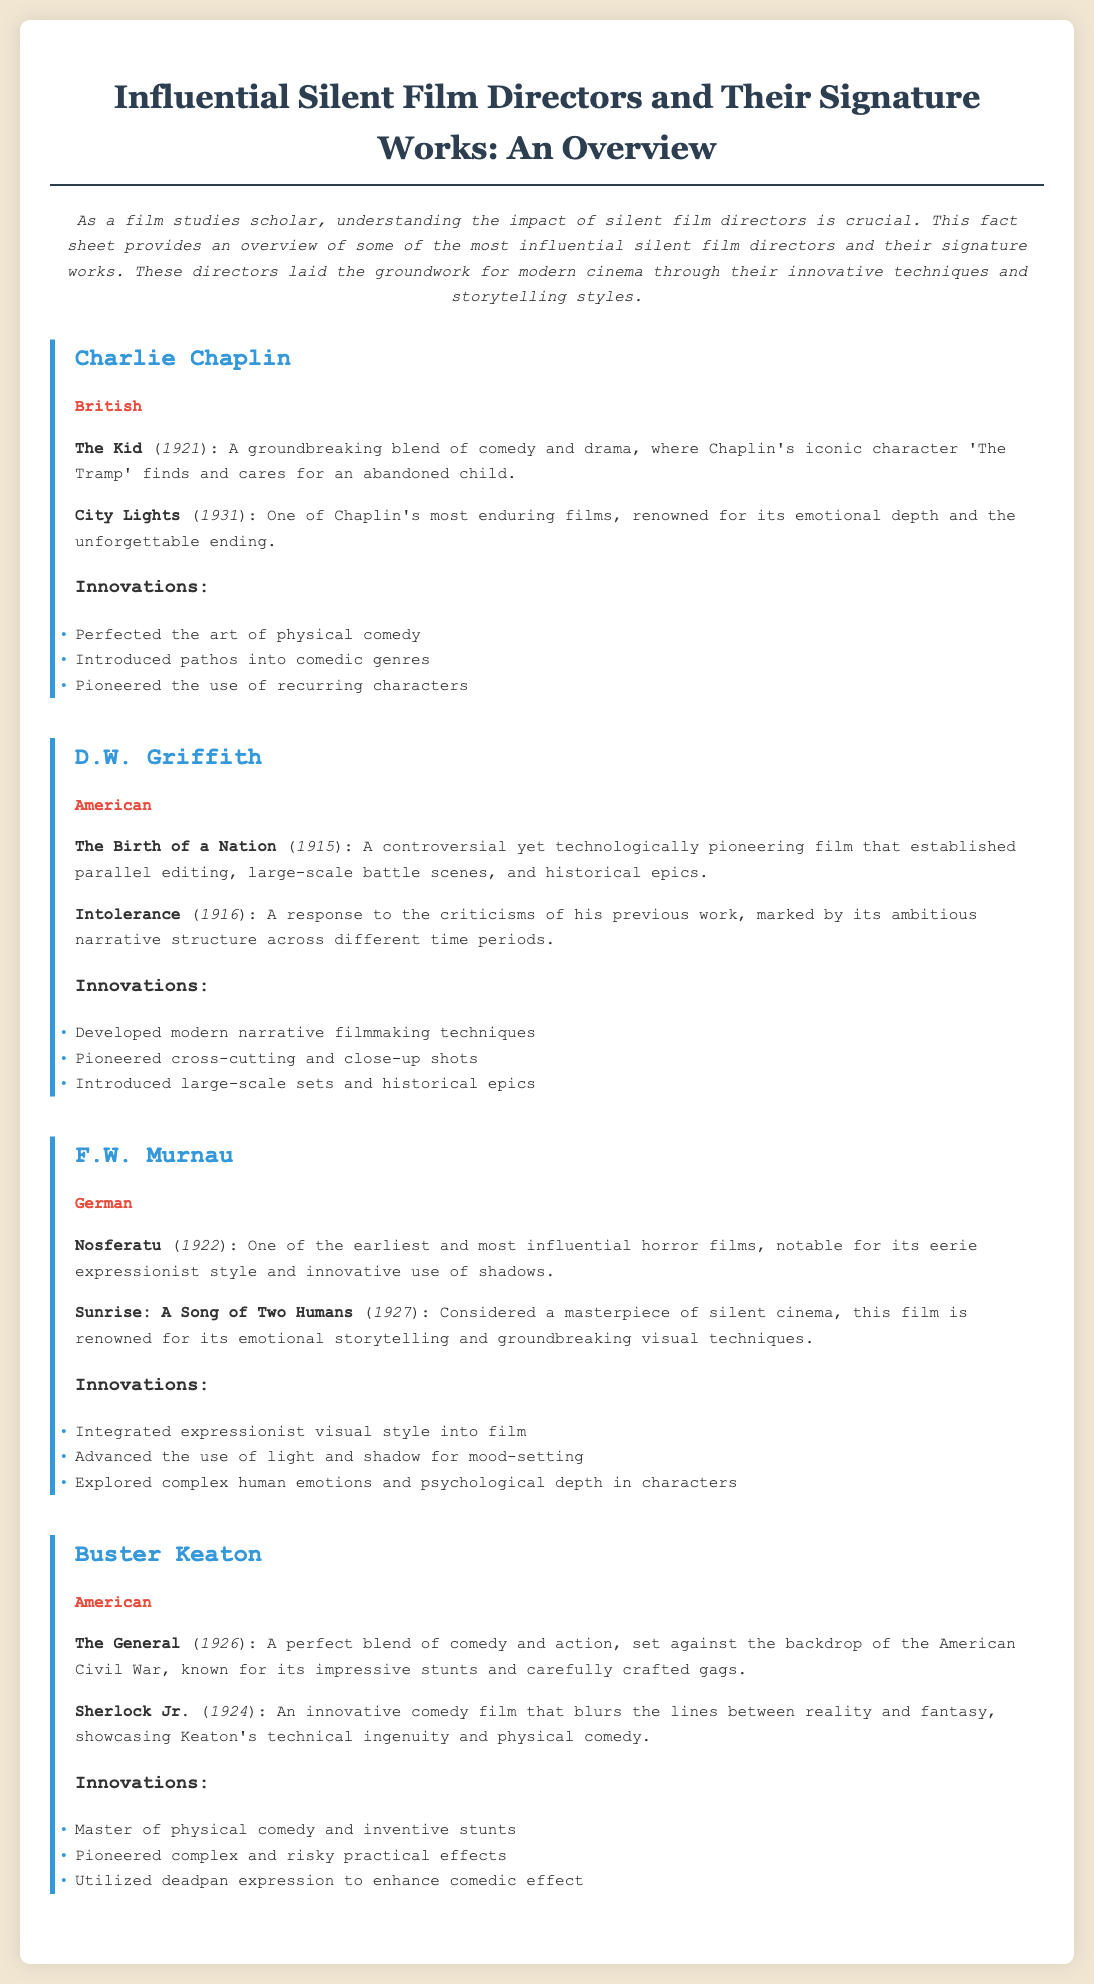what is the nationality of Charlie Chaplin? The document mentions that Charlie Chaplin is British.
Answer: British what is the title of D.W. Griffith's controversial film? The document specifies "The Birth of a Nation" as D.W. Griffith's controversial film.
Answer: The Birth of a Nation which year was "Nosferatu" released? The document states that "Nosferatu" was released in 1922.
Answer: 1922 what is a key innovation introduced by F.W. Murnau? The document lists "Integrated expressionist visual style into film" as a key innovation by F.W. Murnau.
Answer: Integrated expressionist visual style into film name one film directed by Buster Keaton. The document includes "The General" as one of the films directed by Buster Keaton.
Answer: The General who is considered the master of physical comedy? The document indicates that Buster Keaton is the master of physical comedy.
Answer: Buster Keaton what significant narrative technique was pioneered by D.W. Griffith? The document states that D.W. Griffith developed modern narrative filmmaking techniques.
Answer: modern narrative filmmaking techniques which film is renowned for emotional depth and a memorable ending? The document mentions "City Lights" as renowned for its emotional depth and unforgettable ending.
Answer: City Lights how many significant works are listed for Charlie Chaplin? The document details two significant works for Charlie Chaplin.
Answer: two 